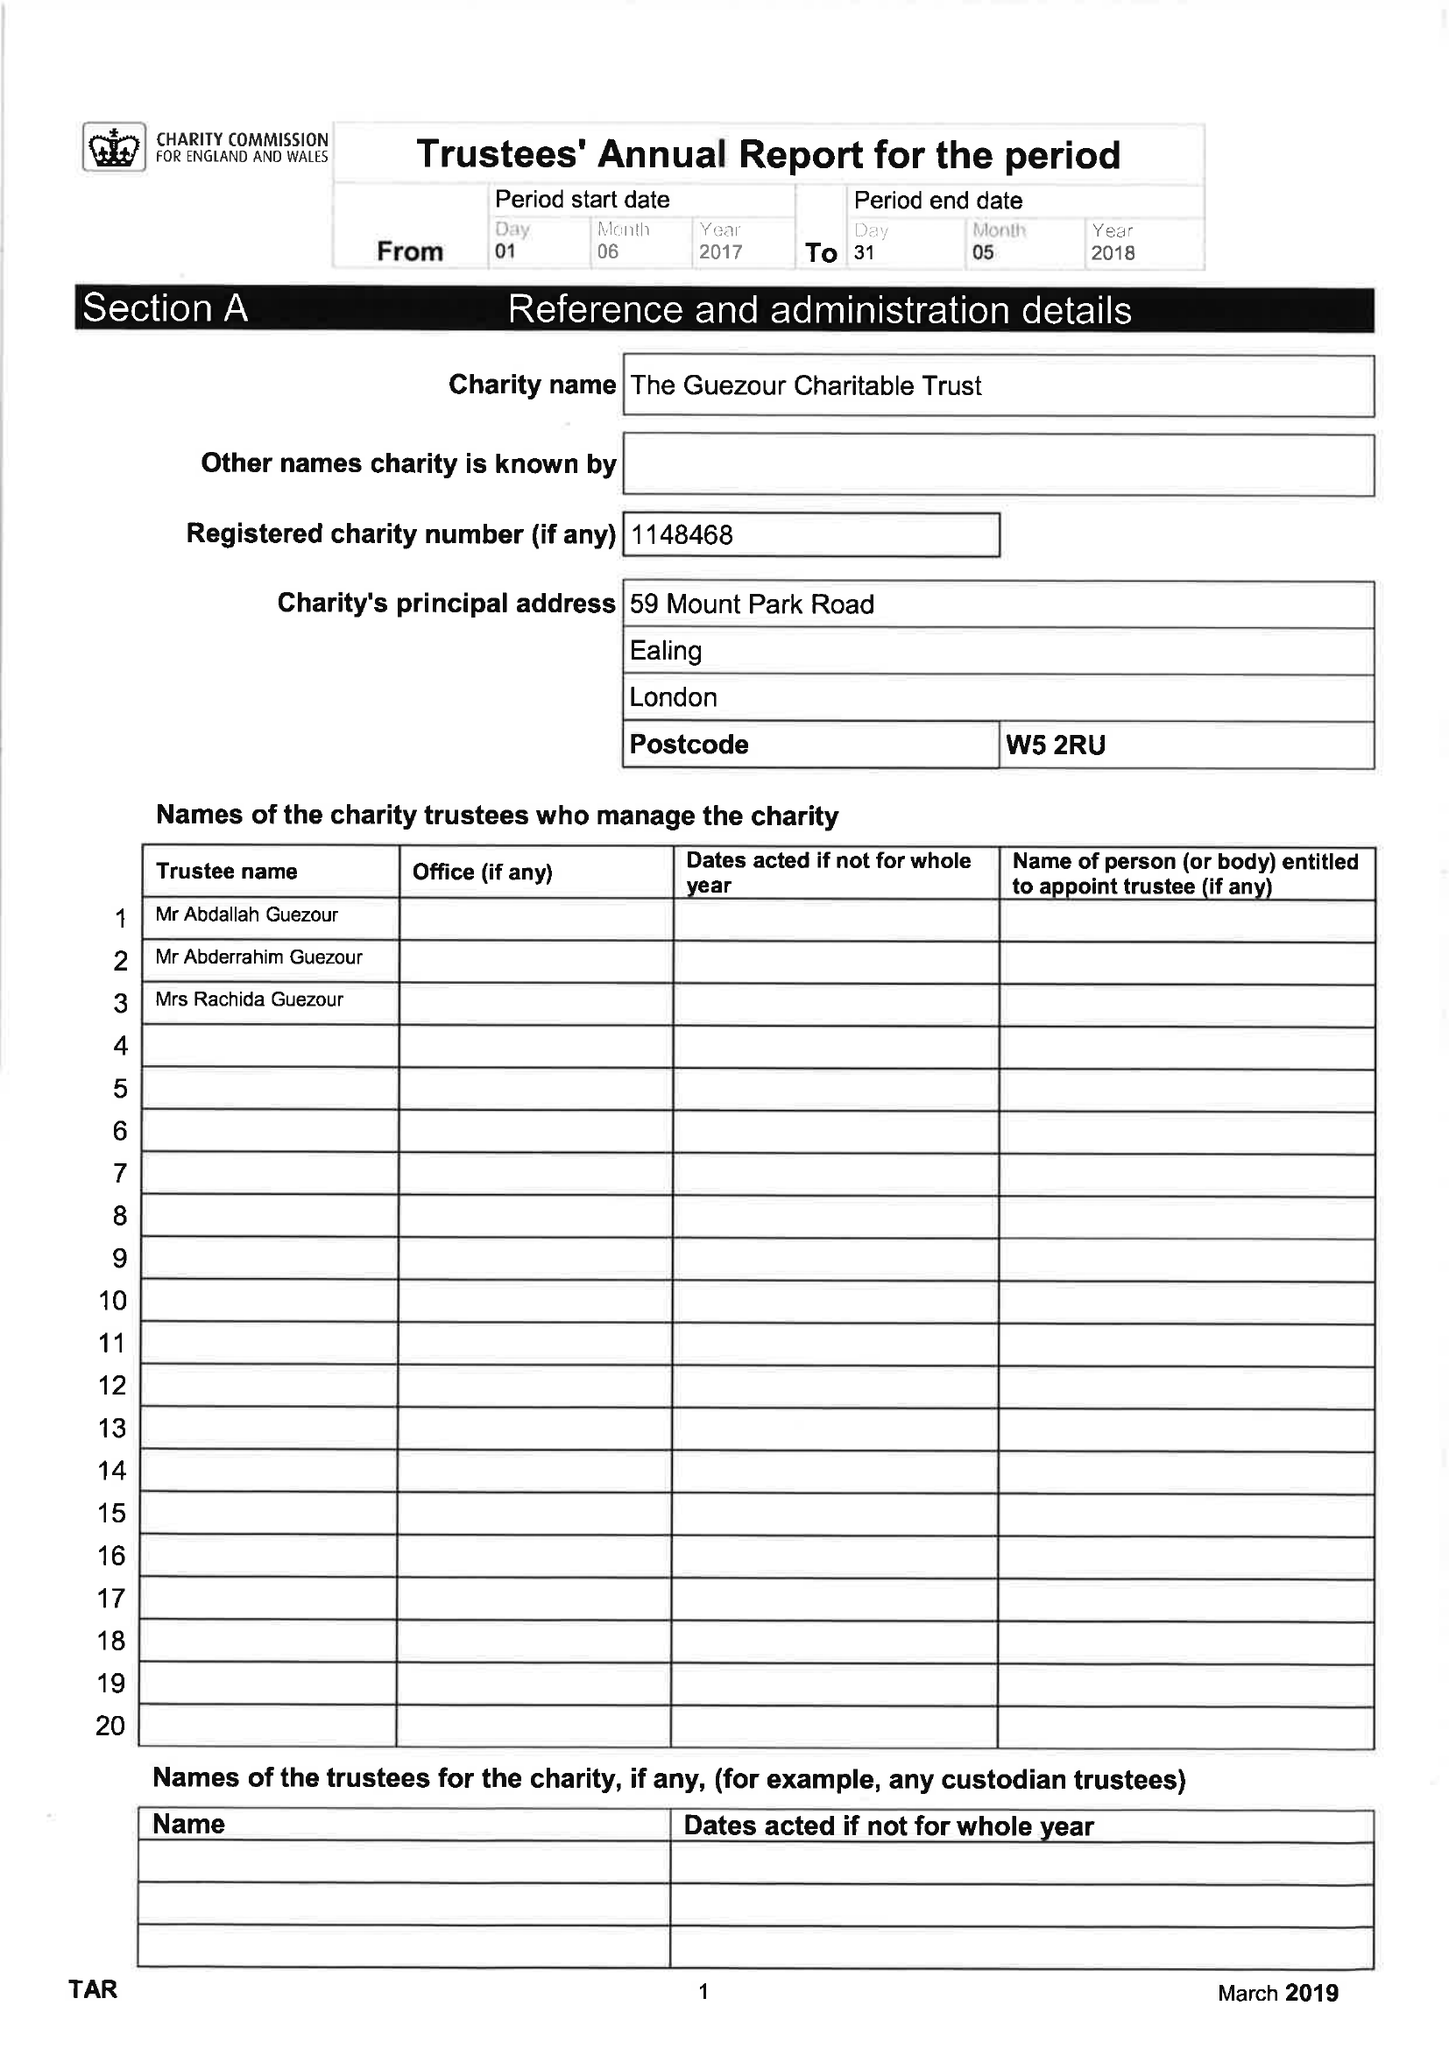What is the value for the charity_name?
Answer the question using a single word or phrase. The Guezour Charitable Trust 